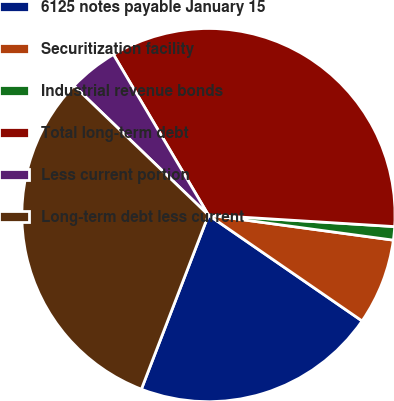Convert chart. <chart><loc_0><loc_0><loc_500><loc_500><pie_chart><fcel>6125 notes payable January 15<fcel>Securitization facility<fcel>Industrial revenue bonds<fcel>Total long-term debt<fcel>Less current portion<fcel>Long-term debt less current<nl><fcel>21.25%<fcel>7.46%<fcel>1.16%<fcel>34.49%<fcel>4.31%<fcel>31.34%<nl></chart> 